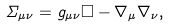Convert formula to latex. <formula><loc_0><loc_0><loc_500><loc_500>\Sigma _ { \mu \nu } = g _ { \mu \nu } \square - \nabla _ { \mu } \nabla _ { \nu } ,</formula> 